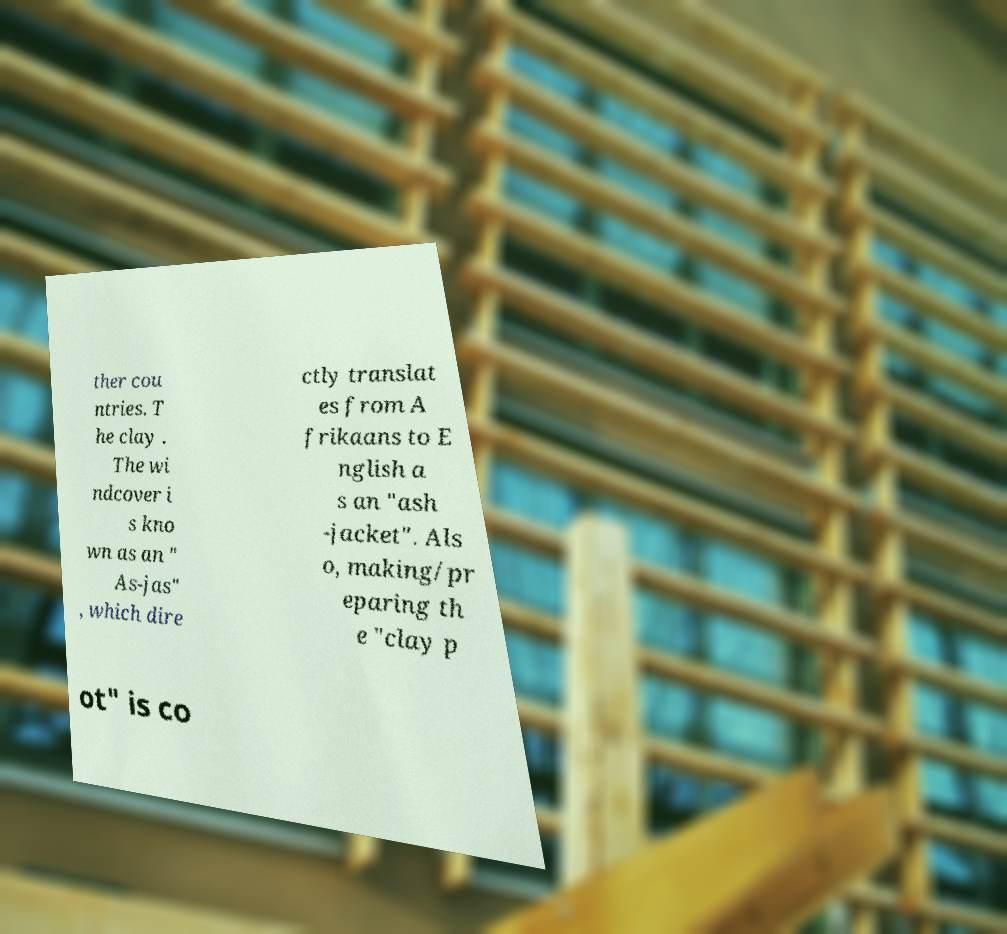Please read and relay the text visible in this image. What does it say? ther cou ntries. T he clay . The wi ndcover i s kno wn as an " As-jas" , which dire ctly translat es from A frikaans to E nglish a s an "ash -jacket". Als o, making/pr eparing th e "clay p ot" is co 